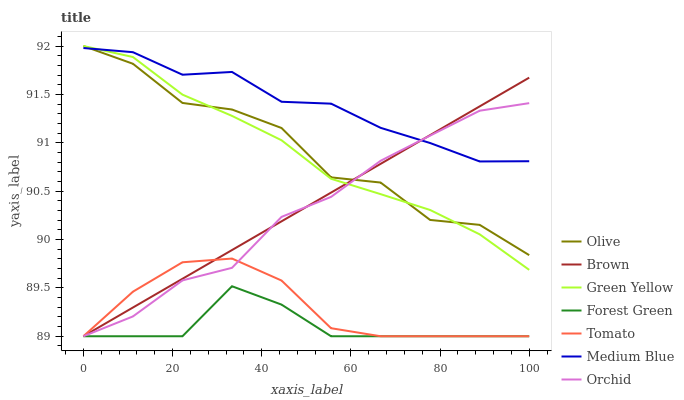Does Brown have the minimum area under the curve?
Answer yes or no. No. Does Brown have the maximum area under the curve?
Answer yes or no. No. Is Medium Blue the smoothest?
Answer yes or no. No. Is Medium Blue the roughest?
Answer yes or no. No. Does Medium Blue have the lowest value?
Answer yes or no. No. Does Brown have the highest value?
Answer yes or no. No. Is Tomato less than Green Yellow?
Answer yes or no. Yes. Is Green Yellow greater than Forest Green?
Answer yes or no. Yes. Does Tomato intersect Green Yellow?
Answer yes or no. No. 